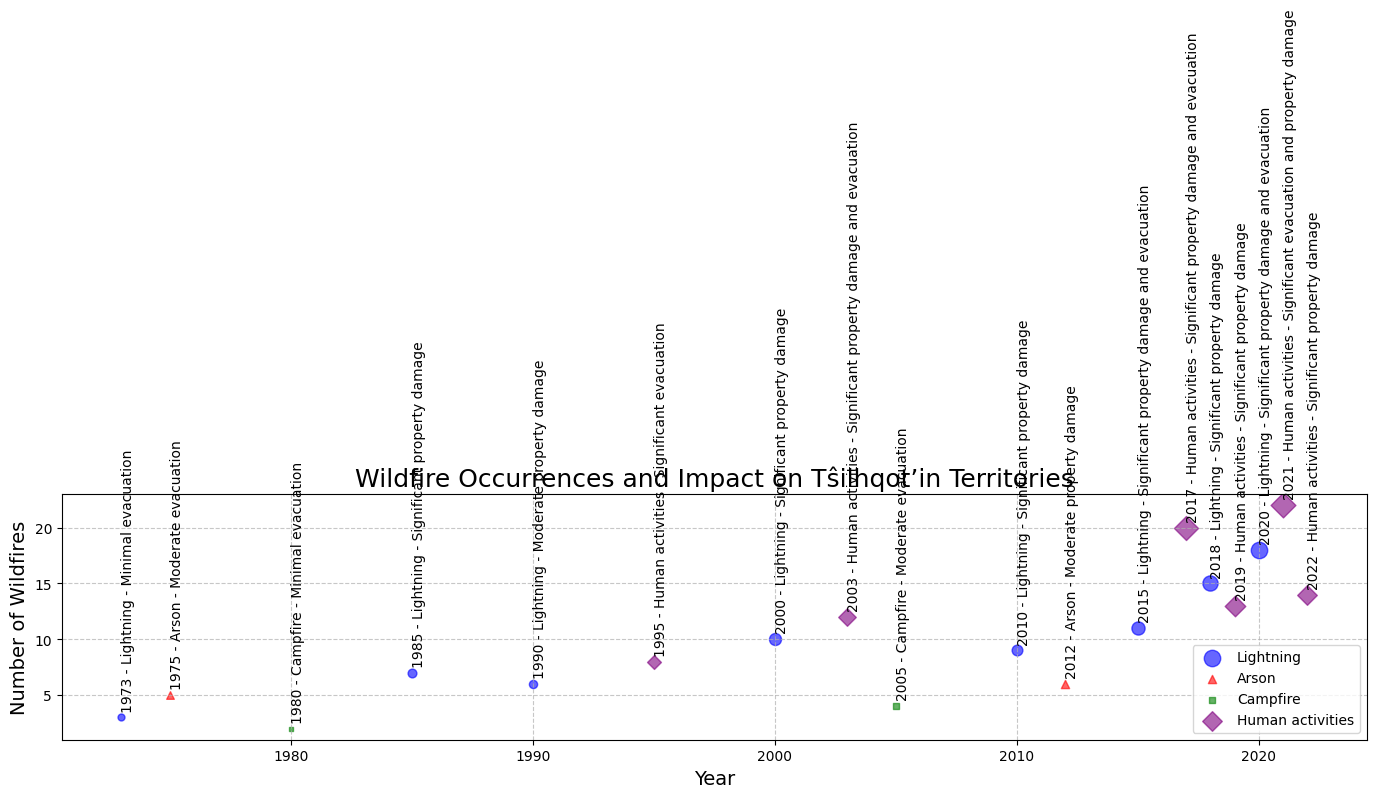What year had the highest number of wildfires? By looking at the scatter plot, observe that the year with the highest y-axis value for the number of wildfires, which is 22. The label near this point shows the year 2021.
Answer: 2021 Which cause of wildfires is most frequently occurring in the data? By examining the different markers on the plot, the 'Lightning' cause, represented by blue circles, appears to be the most frequently occurring.
Answer: Lightning What’s the total affected area for years with significant evacuation and property damage? Identify the years with significant evacuation and property damage labels, which are 2003, 2015, 2017, 2019, 2020, and 2021. Sum the affected areas for these years: 800 + 900 + 1500 + 1100 + 1400 + 1600 = 7300 hectares.
Answer: 7300 hectares How does the number of wildfires caused by human activities compare to those caused by lightning in 2017 and 2018? In 2017, human activities caused 20 wildfires, and in 2018, lightning caused 15 wildfires. Hence, in 2017, the number is greater, and in 2018, it's less.
Answer: 20 > 15 Which year had the largest affected area, and what was the number of wildfires that year? Look for the largest circle on the plot, which represents the largest affected area. The largest circle appears in 2017 corresponding to 1500 hectares, and the number of wildfires in that year is 20.
Answer: 2017, 20 wildfires 